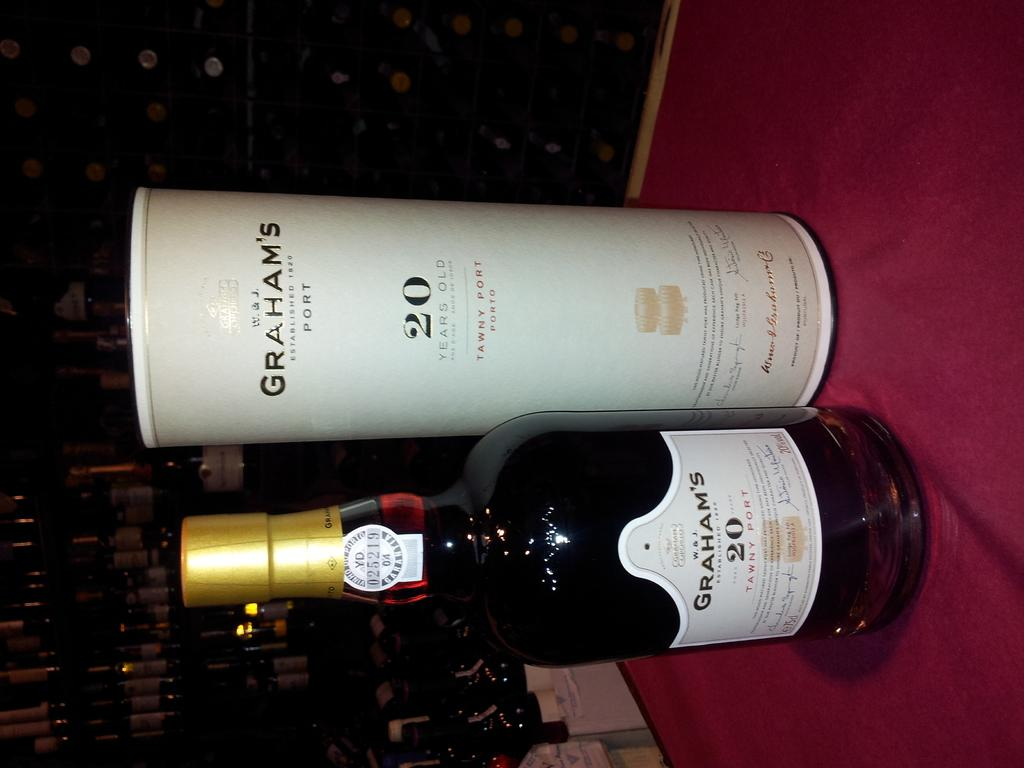<image>
Render a clear and concise summary of the photo. A bottle of Graham's 20 Port stands on a purple table next to its packaging. 